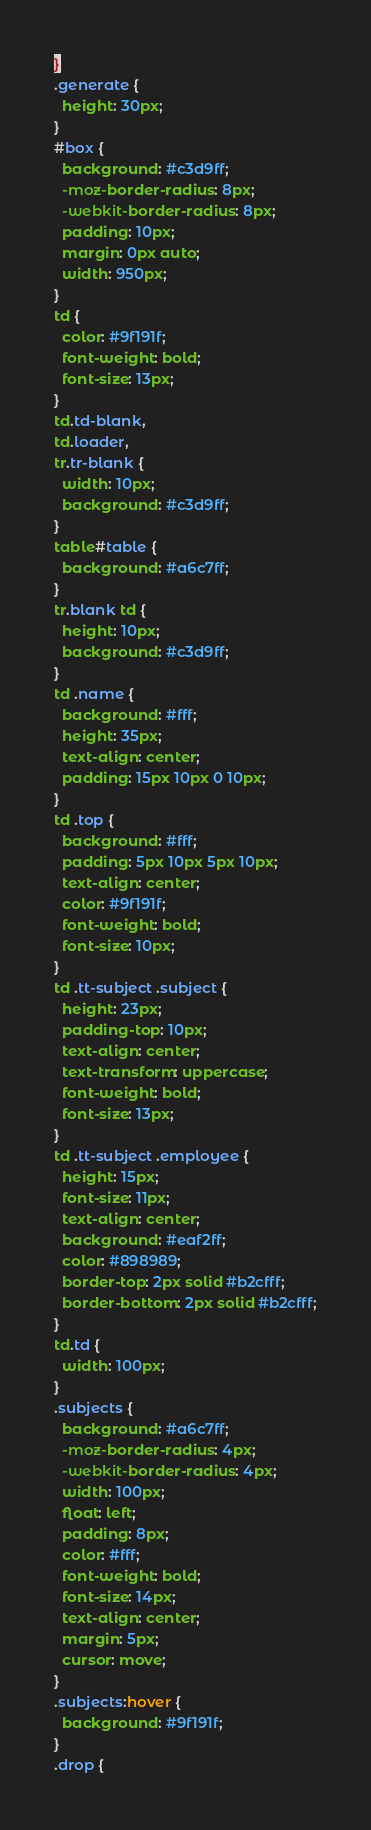Convert code to text. <code><loc_0><loc_0><loc_500><loc_500><_CSS_>}
.generate {
  height: 30px;
}
#box {
  background: #c3d9ff;
  -moz-border-radius: 8px;
  -webkit-border-radius: 8px;
  padding: 10px;
  margin: 0px auto;
  width: 950px;
}
td {
  color: #9f191f;
  font-weight: bold;
  font-size: 13px;
}
td.td-blank,
td.loader,
tr.tr-blank {
  width: 10px;
  background: #c3d9ff;
}
table#table {
  background: #a6c7ff;
}
tr.blank td {
  height: 10px;
  background: #c3d9ff;
}
td .name {
  background: #fff;
  height: 35px;
  text-align: center;
  padding: 15px 10px 0 10px;
}
td .top {
  background: #fff;
  padding: 5px 10px 5px 10px;
  text-align: center;
  color: #9f191f;
  font-weight: bold;
  font-size: 10px;
}
td .tt-subject .subject {
  height: 23px;
  padding-top: 10px;
  text-align: center;
  text-transform: uppercase;
  font-weight: bold;
  font-size: 13px;
}
td .tt-subject .employee {
  height: 15px;
  font-size: 11px;
  text-align: center;
  background: #eaf2ff;
  color: #898989;
  border-top: 2px solid #b2cfff;
  border-bottom: 2px solid #b2cfff;
}
td.td {
  width: 100px;
}
.subjects {
  background: #a6c7ff;
  -moz-border-radius: 4px;
  -webkit-border-radius: 4px;
  width: 100px;
  float: left;
  padding: 8px;
  color: #fff;
  font-weight: bold;
  font-size: 14px;
  text-align: center;
  margin: 5px;
  cursor: move;
}
.subjects:hover {
  background: #9f191f;
}
.drop {</code> 